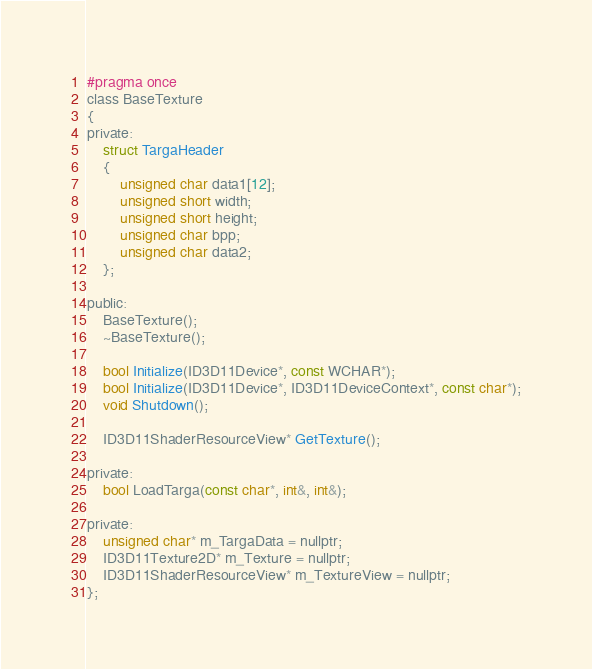<code> <loc_0><loc_0><loc_500><loc_500><_C_>#pragma once
class BaseTexture
{
private:
	struct TargaHeader
	{
		unsigned char data1[12];
		unsigned short width;
		unsigned short height;
		unsigned char bpp;
		unsigned char data2;
	};

public:
	BaseTexture();
	~BaseTexture();

	bool Initialize(ID3D11Device*, const WCHAR*);
	bool Initialize(ID3D11Device*, ID3D11DeviceContext*, const char*);
	void Shutdown();

	ID3D11ShaderResourceView* GetTexture();

private:
	bool LoadTarga(const char*, int&, int&);

private:
	unsigned char* m_TargaData = nullptr;
	ID3D11Texture2D* m_Texture = nullptr;
	ID3D11ShaderResourceView* m_TextureView = nullptr;
};

</code> 